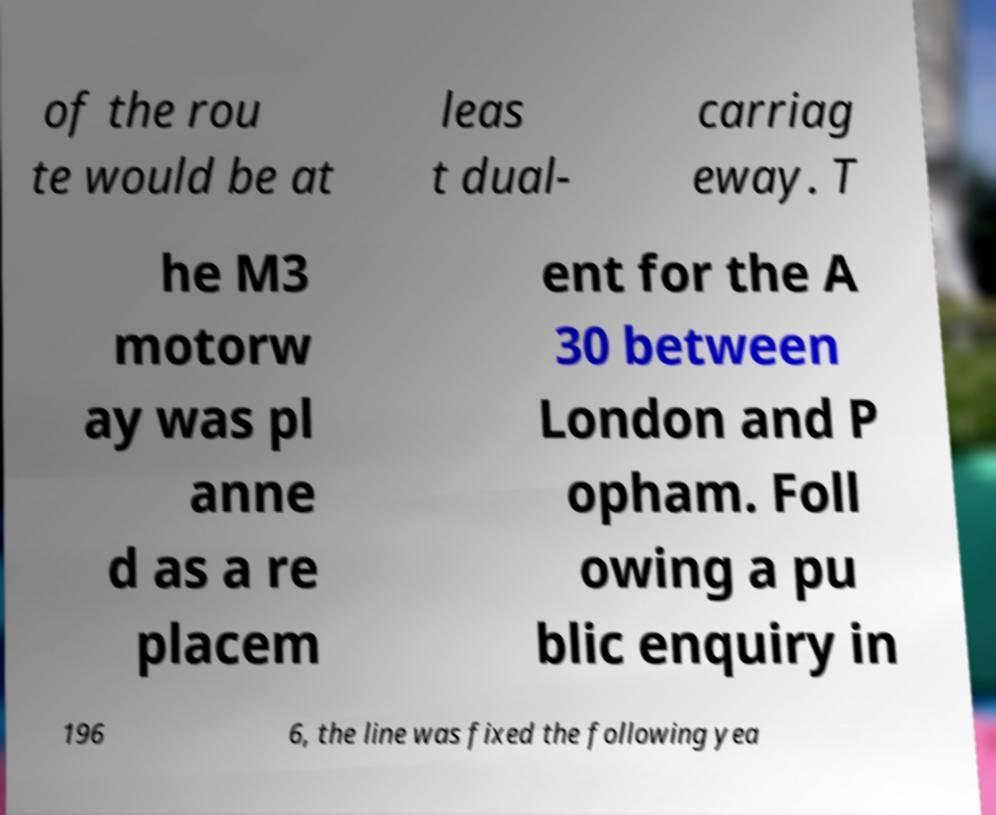There's text embedded in this image that I need extracted. Can you transcribe it verbatim? of the rou te would be at leas t dual- carriag eway. T he M3 motorw ay was pl anne d as a re placem ent for the A 30 between London and P opham. Foll owing a pu blic enquiry in 196 6, the line was fixed the following yea 